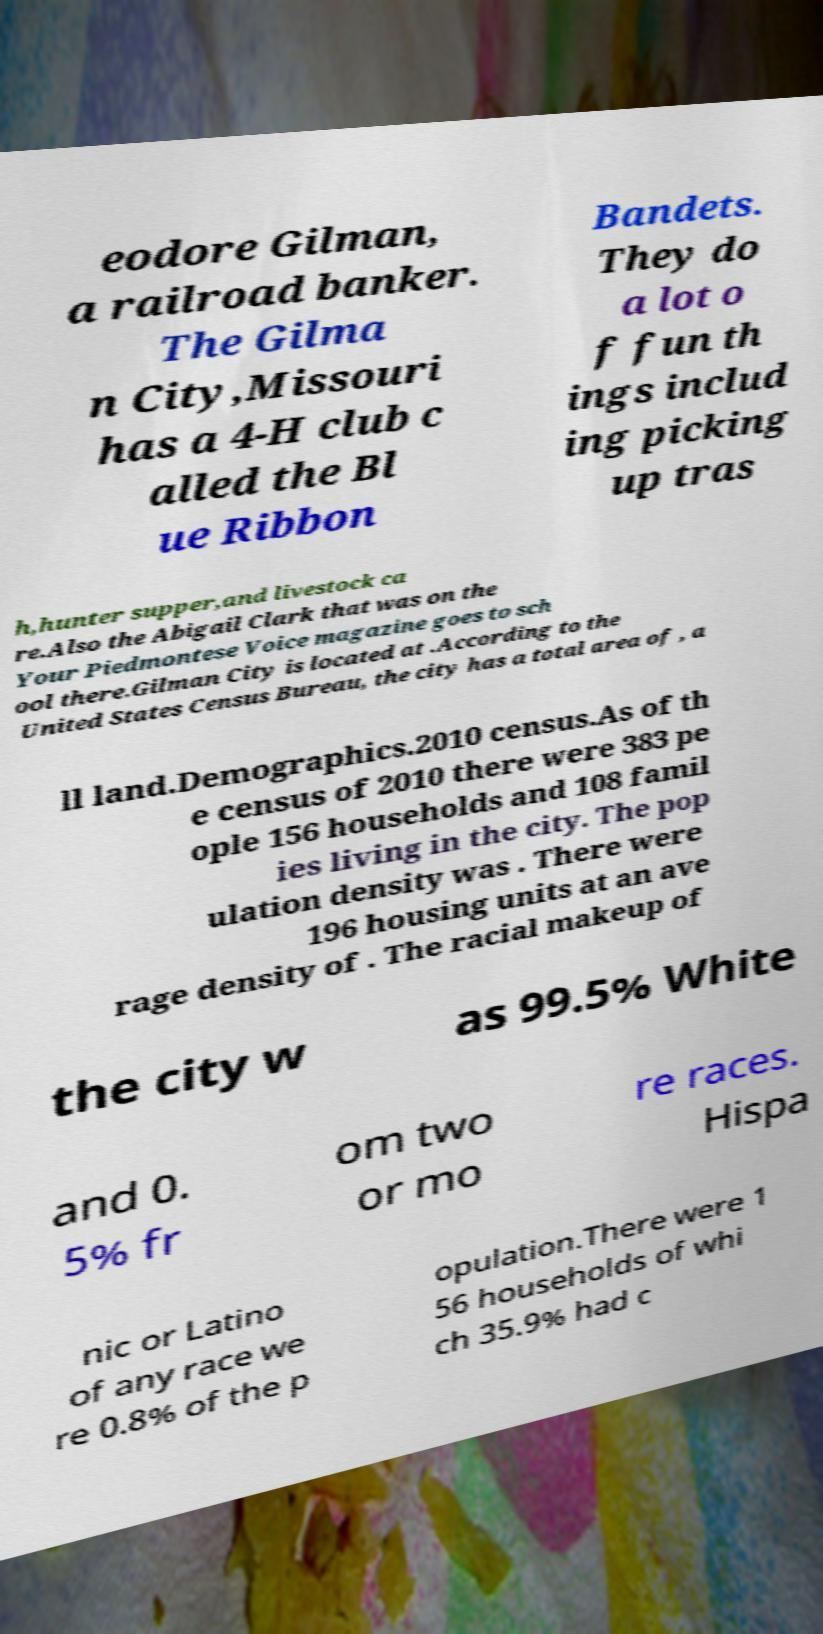Could you assist in decoding the text presented in this image and type it out clearly? eodore Gilman, a railroad banker. The Gilma n City,Missouri has a 4-H club c alled the Bl ue Ribbon Bandets. They do a lot o f fun th ings includ ing picking up tras h,hunter supper,and livestock ca re.Also the Abigail Clark that was on the Your Piedmontese Voice magazine goes to sch ool there.Gilman City is located at .According to the United States Census Bureau, the city has a total area of , a ll land.Demographics.2010 census.As of th e census of 2010 there were 383 pe ople 156 households and 108 famil ies living in the city. The pop ulation density was . There were 196 housing units at an ave rage density of . The racial makeup of the city w as 99.5% White and 0. 5% fr om two or mo re races. Hispa nic or Latino of any race we re 0.8% of the p opulation.There were 1 56 households of whi ch 35.9% had c 